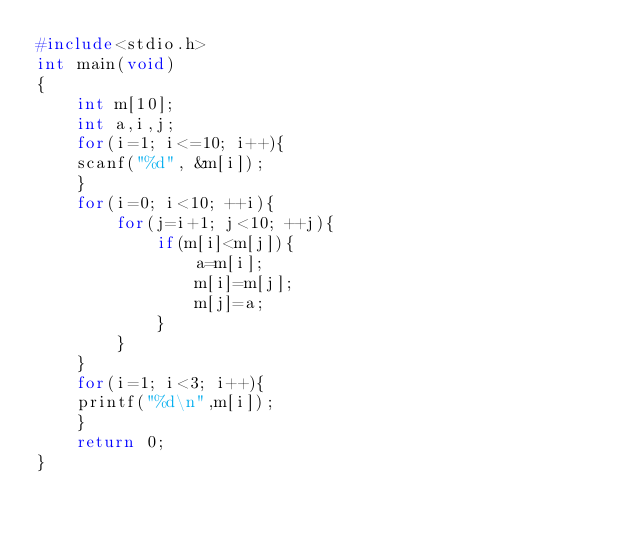Convert code to text. <code><loc_0><loc_0><loc_500><loc_500><_C_>#include<stdio.h>
int main(void)
{
	int m[10];
	int a,i,j;
	for(i=1; i<=10; i++){
	scanf("%d", &m[i]);
	}
	for(i=0; i<10; ++i){
		for(j=i+1; j<10; ++j){
			if(m[i]<m[j]){
				a=m[i];
				m[i]=m[j];
				m[j]=a;
			}
		}
	}
	for(i=1; i<3; i++){
	printf("%d\n",m[i]);
	}
	return 0;
}</code> 